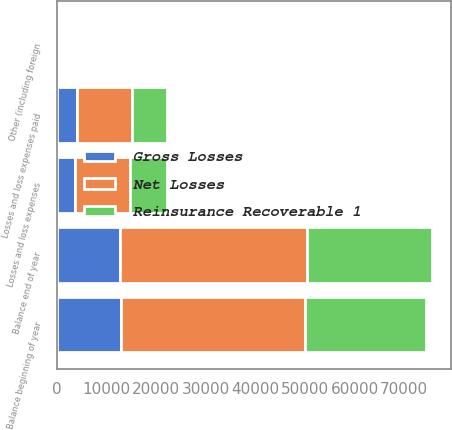Convert chart to OTSL. <chart><loc_0><loc_0><loc_500><loc_500><stacked_bar_chart><ecel><fcel>Balance beginning of year<fcel>Losses and loss expenses<fcel>Losses and loss expenses paid<fcel>Other (including foreign<fcel>Balance end of year<nl><fcel>Net Losses<fcel>37176<fcel>11141<fcel>11093<fcel>559<fcel>37783<nl><fcel>Gross Losses<fcel>12935<fcel>3719<fcel>4145<fcel>236<fcel>12745<nl><fcel>Reinsurance Recoverable 1<fcel>24241<fcel>7422<fcel>6948<fcel>323<fcel>25038<nl></chart> 